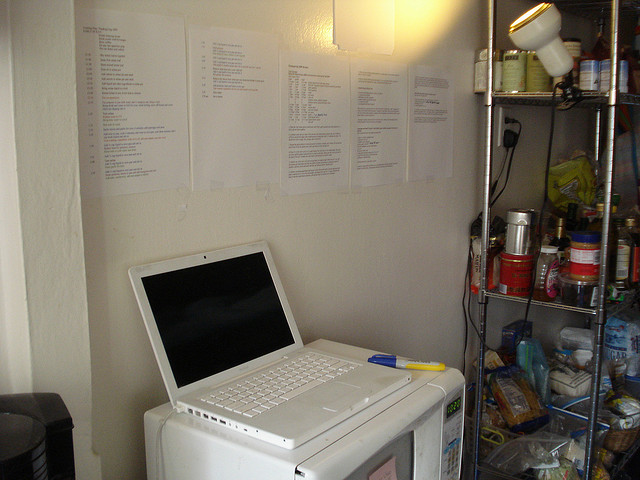How many cans are there in the image? There are 9 cans visible on the shelf to the right side of the image. 